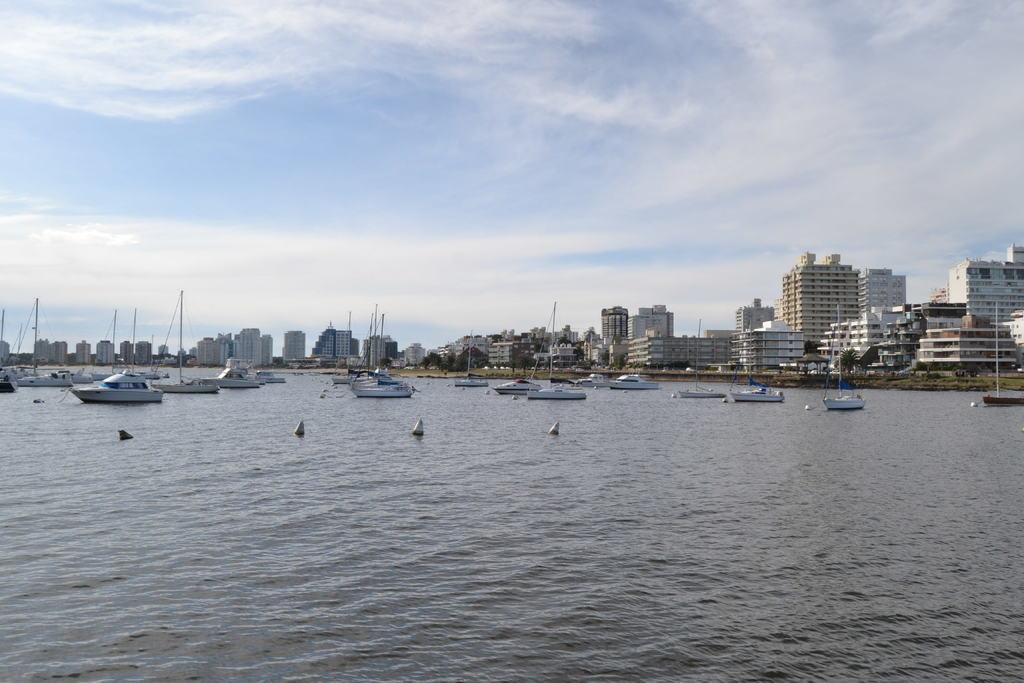What type of vehicles can be seen in the water in the image? There are ships in the water in the image. What structures are visible in the image? There are buildings visible in the image. What objects are present in the image that are taller than the surrounding environment? There are poles in the image. What type of vegetation can be seen in the image? There are trees in the image. What is the color of the sky in the image? The sky is blue and white in color. What type of bed can be seen in the image? There is no bed present in the image. What type of protest is taking place in the image? There is no protest present in the image. 